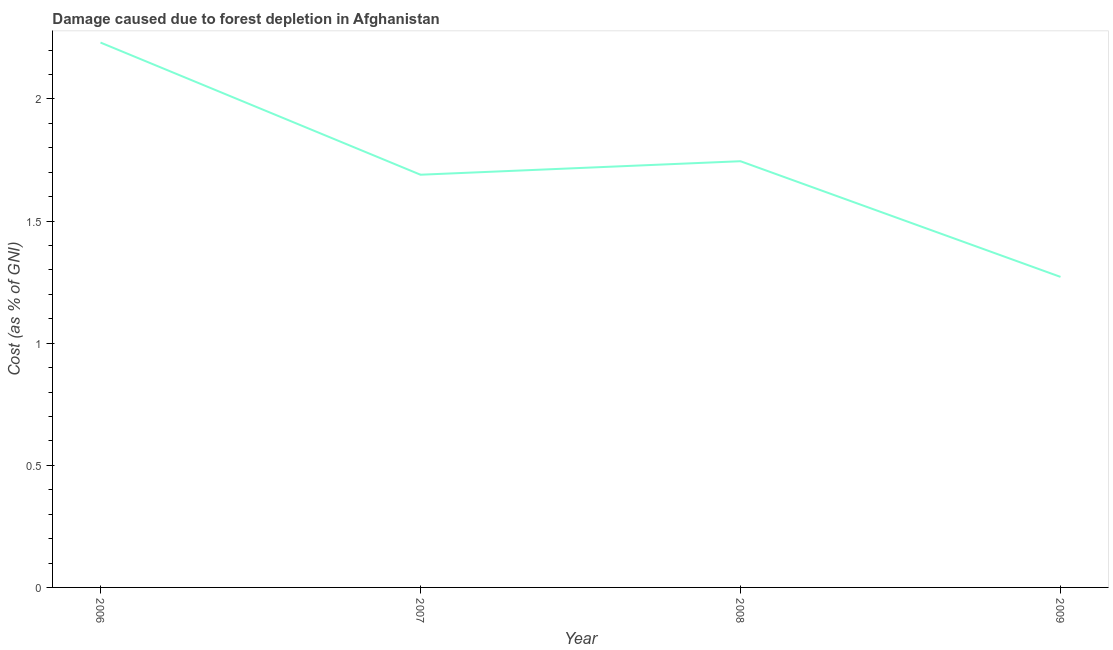What is the damage caused due to forest depletion in 2006?
Your answer should be compact. 2.23. Across all years, what is the maximum damage caused due to forest depletion?
Make the answer very short. 2.23. Across all years, what is the minimum damage caused due to forest depletion?
Your answer should be compact. 1.27. What is the sum of the damage caused due to forest depletion?
Make the answer very short. 6.94. What is the difference between the damage caused due to forest depletion in 2006 and 2007?
Offer a terse response. 0.54. What is the average damage caused due to forest depletion per year?
Offer a terse response. 1.73. What is the median damage caused due to forest depletion?
Your answer should be very brief. 1.72. What is the ratio of the damage caused due to forest depletion in 2007 to that in 2008?
Provide a succinct answer. 0.97. Is the difference between the damage caused due to forest depletion in 2007 and 2008 greater than the difference between any two years?
Your response must be concise. No. What is the difference between the highest and the second highest damage caused due to forest depletion?
Your answer should be compact. 0.49. What is the difference between the highest and the lowest damage caused due to forest depletion?
Provide a succinct answer. 0.96. In how many years, is the damage caused due to forest depletion greater than the average damage caused due to forest depletion taken over all years?
Offer a terse response. 2. How many lines are there?
Keep it short and to the point. 1. What is the difference between two consecutive major ticks on the Y-axis?
Give a very brief answer. 0.5. Does the graph contain any zero values?
Keep it short and to the point. No. What is the title of the graph?
Offer a very short reply. Damage caused due to forest depletion in Afghanistan. What is the label or title of the Y-axis?
Offer a terse response. Cost (as % of GNI). What is the Cost (as % of GNI) in 2006?
Ensure brevity in your answer.  2.23. What is the Cost (as % of GNI) in 2007?
Make the answer very short. 1.69. What is the Cost (as % of GNI) of 2008?
Your response must be concise. 1.74. What is the Cost (as % of GNI) in 2009?
Give a very brief answer. 1.27. What is the difference between the Cost (as % of GNI) in 2006 and 2007?
Provide a short and direct response. 0.54. What is the difference between the Cost (as % of GNI) in 2006 and 2008?
Keep it short and to the point. 0.49. What is the difference between the Cost (as % of GNI) in 2006 and 2009?
Offer a very short reply. 0.96. What is the difference between the Cost (as % of GNI) in 2007 and 2008?
Your response must be concise. -0.06. What is the difference between the Cost (as % of GNI) in 2007 and 2009?
Keep it short and to the point. 0.42. What is the difference between the Cost (as % of GNI) in 2008 and 2009?
Keep it short and to the point. 0.47. What is the ratio of the Cost (as % of GNI) in 2006 to that in 2007?
Provide a short and direct response. 1.32. What is the ratio of the Cost (as % of GNI) in 2006 to that in 2008?
Provide a short and direct response. 1.28. What is the ratio of the Cost (as % of GNI) in 2006 to that in 2009?
Keep it short and to the point. 1.75. What is the ratio of the Cost (as % of GNI) in 2007 to that in 2008?
Provide a succinct answer. 0.97. What is the ratio of the Cost (as % of GNI) in 2007 to that in 2009?
Give a very brief answer. 1.33. What is the ratio of the Cost (as % of GNI) in 2008 to that in 2009?
Provide a succinct answer. 1.37. 